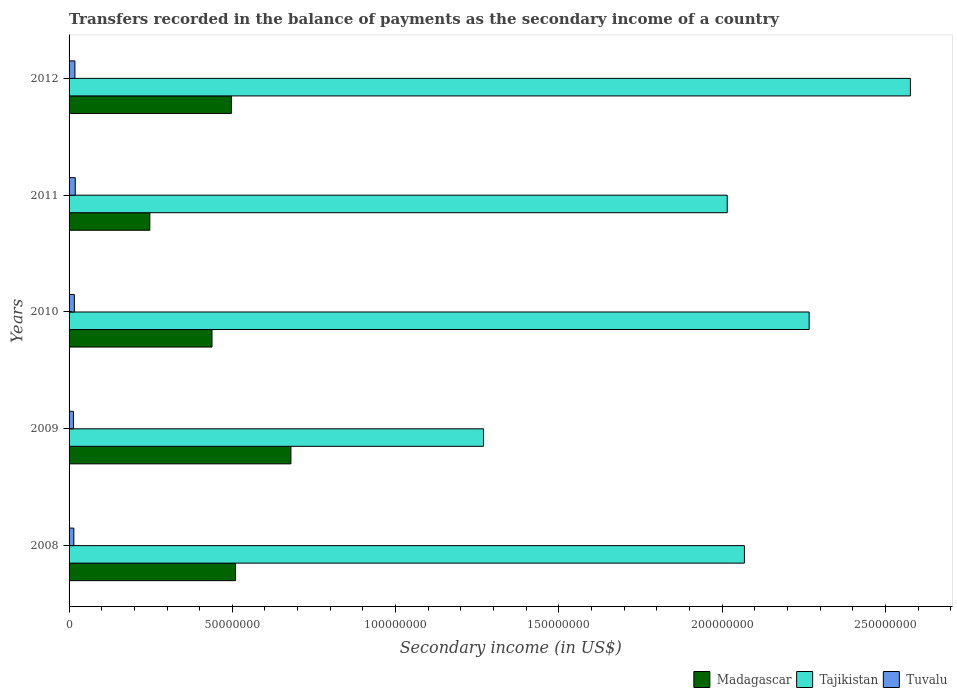How many different coloured bars are there?
Ensure brevity in your answer.  3. How many groups of bars are there?
Your answer should be very brief. 5. Are the number of bars per tick equal to the number of legend labels?
Your answer should be very brief. Yes. How many bars are there on the 4th tick from the top?
Offer a terse response. 3. What is the label of the 5th group of bars from the top?
Make the answer very short. 2008. In how many cases, is the number of bars for a given year not equal to the number of legend labels?
Provide a succinct answer. 0. What is the secondary income of in Madagascar in 2010?
Offer a very short reply. 4.38e+07. Across all years, what is the maximum secondary income of in Tajikistan?
Offer a very short reply. 2.58e+08. Across all years, what is the minimum secondary income of in Tuvalu?
Offer a terse response. 1.33e+06. In which year was the secondary income of in Tuvalu maximum?
Provide a succinct answer. 2011. What is the total secondary income of in Madagascar in the graph?
Provide a succinct answer. 2.37e+08. What is the difference between the secondary income of in Madagascar in 2011 and that in 2012?
Your answer should be compact. -2.50e+07. What is the difference between the secondary income of in Madagascar in 2010 and the secondary income of in Tajikistan in 2008?
Give a very brief answer. -1.63e+08. What is the average secondary income of in Madagascar per year?
Offer a terse response. 4.74e+07. In the year 2012, what is the difference between the secondary income of in Tuvalu and secondary income of in Madagascar?
Give a very brief answer. -4.79e+07. In how many years, is the secondary income of in Madagascar greater than 240000000 US$?
Your answer should be compact. 0. What is the ratio of the secondary income of in Madagascar in 2009 to that in 2012?
Provide a short and direct response. 1.37. Is the difference between the secondary income of in Tuvalu in 2009 and 2012 greater than the difference between the secondary income of in Madagascar in 2009 and 2012?
Provide a short and direct response. No. What is the difference between the highest and the second highest secondary income of in Madagascar?
Your response must be concise. 1.70e+07. What is the difference between the highest and the lowest secondary income of in Madagascar?
Your response must be concise. 4.32e+07. In how many years, is the secondary income of in Tuvalu greater than the average secondary income of in Tuvalu taken over all years?
Offer a very short reply. 2. What does the 2nd bar from the top in 2012 represents?
Your answer should be very brief. Tajikistan. What does the 2nd bar from the bottom in 2009 represents?
Keep it short and to the point. Tajikistan. Is it the case that in every year, the sum of the secondary income of in Madagascar and secondary income of in Tuvalu is greater than the secondary income of in Tajikistan?
Your response must be concise. No. Are all the bars in the graph horizontal?
Provide a succinct answer. Yes. What is the difference between two consecutive major ticks on the X-axis?
Provide a succinct answer. 5.00e+07. Does the graph contain grids?
Ensure brevity in your answer.  No. Where does the legend appear in the graph?
Keep it short and to the point. Bottom right. How many legend labels are there?
Give a very brief answer. 3. How are the legend labels stacked?
Provide a succinct answer. Horizontal. What is the title of the graph?
Provide a succinct answer. Transfers recorded in the balance of payments as the secondary income of a country. Does "Brunei Darussalam" appear as one of the legend labels in the graph?
Ensure brevity in your answer.  No. What is the label or title of the X-axis?
Give a very brief answer. Secondary income (in US$). What is the label or title of the Y-axis?
Your answer should be very brief. Years. What is the Secondary income (in US$) in Madagascar in 2008?
Offer a very short reply. 5.10e+07. What is the Secondary income (in US$) of Tajikistan in 2008?
Your answer should be compact. 2.07e+08. What is the Secondary income (in US$) in Tuvalu in 2008?
Provide a succinct answer. 1.46e+06. What is the Secondary income (in US$) of Madagascar in 2009?
Your answer should be compact. 6.79e+07. What is the Secondary income (in US$) of Tajikistan in 2009?
Offer a very short reply. 1.27e+08. What is the Secondary income (in US$) of Tuvalu in 2009?
Ensure brevity in your answer.  1.33e+06. What is the Secondary income (in US$) in Madagascar in 2010?
Make the answer very short. 4.38e+07. What is the Secondary income (in US$) of Tajikistan in 2010?
Offer a terse response. 2.27e+08. What is the Secondary income (in US$) of Tuvalu in 2010?
Ensure brevity in your answer.  1.61e+06. What is the Secondary income (in US$) in Madagascar in 2011?
Offer a very short reply. 2.47e+07. What is the Secondary income (in US$) of Tajikistan in 2011?
Provide a succinct answer. 2.02e+08. What is the Secondary income (in US$) in Tuvalu in 2011?
Make the answer very short. 1.89e+06. What is the Secondary income (in US$) in Madagascar in 2012?
Give a very brief answer. 4.97e+07. What is the Secondary income (in US$) in Tajikistan in 2012?
Provide a succinct answer. 2.58e+08. What is the Secondary income (in US$) in Tuvalu in 2012?
Provide a short and direct response. 1.79e+06. Across all years, what is the maximum Secondary income (in US$) of Madagascar?
Keep it short and to the point. 6.79e+07. Across all years, what is the maximum Secondary income (in US$) of Tajikistan?
Make the answer very short. 2.58e+08. Across all years, what is the maximum Secondary income (in US$) in Tuvalu?
Give a very brief answer. 1.89e+06. Across all years, what is the minimum Secondary income (in US$) of Madagascar?
Give a very brief answer. 2.47e+07. Across all years, what is the minimum Secondary income (in US$) in Tajikistan?
Your answer should be compact. 1.27e+08. Across all years, what is the minimum Secondary income (in US$) of Tuvalu?
Offer a very short reply. 1.33e+06. What is the total Secondary income (in US$) of Madagascar in the graph?
Give a very brief answer. 2.37e+08. What is the total Secondary income (in US$) in Tajikistan in the graph?
Your answer should be very brief. 1.02e+09. What is the total Secondary income (in US$) of Tuvalu in the graph?
Keep it short and to the point. 8.09e+06. What is the difference between the Secondary income (in US$) in Madagascar in 2008 and that in 2009?
Your answer should be compact. -1.70e+07. What is the difference between the Secondary income (in US$) in Tajikistan in 2008 and that in 2009?
Provide a short and direct response. 7.99e+07. What is the difference between the Secondary income (in US$) in Tuvalu in 2008 and that in 2009?
Your answer should be very brief. 1.27e+05. What is the difference between the Secondary income (in US$) of Madagascar in 2008 and that in 2010?
Your answer should be very brief. 7.18e+06. What is the difference between the Secondary income (in US$) of Tajikistan in 2008 and that in 2010?
Provide a succinct answer. -1.98e+07. What is the difference between the Secondary income (in US$) of Tuvalu in 2008 and that in 2010?
Keep it short and to the point. -1.53e+05. What is the difference between the Secondary income (in US$) of Madagascar in 2008 and that in 2011?
Provide a succinct answer. 2.62e+07. What is the difference between the Secondary income (in US$) in Tajikistan in 2008 and that in 2011?
Offer a terse response. 5.26e+06. What is the difference between the Secondary income (in US$) of Tuvalu in 2008 and that in 2011?
Keep it short and to the point. -4.32e+05. What is the difference between the Secondary income (in US$) in Madagascar in 2008 and that in 2012?
Provide a short and direct response. 1.25e+06. What is the difference between the Secondary income (in US$) of Tajikistan in 2008 and that in 2012?
Provide a succinct answer. -5.08e+07. What is the difference between the Secondary income (in US$) of Tuvalu in 2008 and that in 2012?
Make the answer very short. -3.24e+05. What is the difference between the Secondary income (in US$) in Madagascar in 2009 and that in 2010?
Your answer should be very brief. 2.42e+07. What is the difference between the Secondary income (in US$) of Tajikistan in 2009 and that in 2010?
Offer a very short reply. -9.97e+07. What is the difference between the Secondary income (in US$) in Tuvalu in 2009 and that in 2010?
Ensure brevity in your answer.  -2.80e+05. What is the difference between the Secondary income (in US$) in Madagascar in 2009 and that in 2011?
Keep it short and to the point. 4.32e+07. What is the difference between the Secondary income (in US$) in Tajikistan in 2009 and that in 2011?
Make the answer very short. -7.46e+07. What is the difference between the Secondary income (in US$) in Tuvalu in 2009 and that in 2011?
Your response must be concise. -5.59e+05. What is the difference between the Secondary income (in US$) of Madagascar in 2009 and that in 2012?
Your answer should be very brief. 1.82e+07. What is the difference between the Secondary income (in US$) of Tajikistan in 2009 and that in 2012?
Offer a very short reply. -1.31e+08. What is the difference between the Secondary income (in US$) of Tuvalu in 2009 and that in 2012?
Provide a short and direct response. -4.51e+05. What is the difference between the Secondary income (in US$) of Madagascar in 2010 and that in 2011?
Keep it short and to the point. 1.90e+07. What is the difference between the Secondary income (in US$) in Tajikistan in 2010 and that in 2011?
Keep it short and to the point. 2.51e+07. What is the difference between the Secondary income (in US$) of Tuvalu in 2010 and that in 2011?
Provide a short and direct response. -2.80e+05. What is the difference between the Secondary income (in US$) of Madagascar in 2010 and that in 2012?
Keep it short and to the point. -5.93e+06. What is the difference between the Secondary income (in US$) in Tajikistan in 2010 and that in 2012?
Give a very brief answer. -3.10e+07. What is the difference between the Secondary income (in US$) in Tuvalu in 2010 and that in 2012?
Ensure brevity in your answer.  -1.71e+05. What is the difference between the Secondary income (in US$) of Madagascar in 2011 and that in 2012?
Your answer should be very brief. -2.50e+07. What is the difference between the Secondary income (in US$) in Tajikistan in 2011 and that in 2012?
Ensure brevity in your answer.  -5.61e+07. What is the difference between the Secondary income (in US$) in Tuvalu in 2011 and that in 2012?
Your answer should be very brief. 1.08e+05. What is the difference between the Secondary income (in US$) in Madagascar in 2008 and the Secondary income (in US$) in Tajikistan in 2009?
Your response must be concise. -7.60e+07. What is the difference between the Secondary income (in US$) of Madagascar in 2008 and the Secondary income (in US$) of Tuvalu in 2009?
Offer a terse response. 4.96e+07. What is the difference between the Secondary income (in US$) of Tajikistan in 2008 and the Secondary income (in US$) of Tuvalu in 2009?
Ensure brevity in your answer.  2.05e+08. What is the difference between the Secondary income (in US$) in Madagascar in 2008 and the Secondary income (in US$) in Tajikistan in 2010?
Provide a succinct answer. -1.76e+08. What is the difference between the Secondary income (in US$) of Madagascar in 2008 and the Secondary income (in US$) of Tuvalu in 2010?
Provide a short and direct response. 4.93e+07. What is the difference between the Secondary income (in US$) of Tajikistan in 2008 and the Secondary income (in US$) of Tuvalu in 2010?
Give a very brief answer. 2.05e+08. What is the difference between the Secondary income (in US$) in Madagascar in 2008 and the Secondary income (in US$) in Tajikistan in 2011?
Your answer should be compact. -1.51e+08. What is the difference between the Secondary income (in US$) in Madagascar in 2008 and the Secondary income (in US$) in Tuvalu in 2011?
Provide a succinct answer. 4.91e+07. What is the difference between the Secondary income (in US$) in Tajikistan in 2008 and the Secondary income (in US$) in Tuvalu in 2011?
Make the answer very short. 2.05e+08. What is the difference between the Secondary income (in US$) of Madagascar in 2008 and the Secondary income (in US$) of Tajikistan in 2012?
Provide a short and direct response. -2.07e+08. What is the difference between the Secondary income (in US$) in Madagascar in 2008 and the Secondary income (in US$) in Tuvalu in 2012?
Offer a very short reply. 4.92e+07. What is the difference between the Secondary income (in US$) in Tajikistan in 2008 and the Secondary income (in US$) in Tuvalu in 2012?
Offer a very short reply. 2.05e+08. What is the difference between the Secondary income (in US$) of Madagascar in 2009 and the Secondary income (in US$) of Tajikistan in 2010?
Your answer should be very brief. -1.59e+08. What is the difference between the Secondary income (in US$) in Madagascar in 2009 and the Secondary income (in US$) in Tuvalu in 2010?
Keep it short and to the point. 6.63e+07. What is the difference between the Secondary income (in US$) in Tajikistan in 2009 and the Secondary income (in US$) in Tuvalu in 2010?
Make the answer very short. 1.25e+08. What is the difference between the Secondary income (in US$) in Madagascar in 2009 and the Secondary income (in US$) in Tajikistan in 2011?
Offer a very short reply. -1.34e+08. What is the difference between the Secondary income (in US$) in Madagascar in 2009 and the Secondary income (in US$) in Tuvalu in 2011?
Provide a succinct answer. 6.60e+07. What is the difference between the Secondary income (in US$) in Tajikistan in 2009 and the Secondary income (in US$) in Tuvalu in 2011?
Your response must be concise. 1.25e+08. What is the difference between the Secondary income (in US$) in Madagascar in 2009 and the Secondary income (in US$) in Tajikistan in 2012?
Offer a very short reply. -1.90e+08. What is the difference between the Secondary income (in US$) in Madagascar in 2009 and the Secondary income (in US$) in Tuvalu in 2012?
Provide a short and direct response. 6.62e+07. What is the difference between the Secondary income (in US$) in Tajikistan in 2009 and the Secondary income (in US$) in Tuvalu in 2012?
Keep it short and to the point. 1.25e+08. What is the difference between the Secondary income (in US$) of Madagascar in 2010 and the Secondary income (in US$) of Tajikistan in 2011?
Your answer should be very brief. -1.58e+08. What is the difference between the Secondary income (in US$) of Madagascar in 2010 and the Secondary income (in US$) of Tuvalu in 2011?
Make the answer very short. 4.19e+07. What is the difference between the Secondary income (in US$) of Tajikistan in 2010 and the Secondary income (in US$) of Tuvalu in 2011?
Your answer should be compact. 2.25e+08. What is the difference between the Secondary income (in US$) of Madagascar in 2010 and the Secondary income (in US$) of Tajikistan in 2012?
Make the answer very short. -2.14e+08. What is the difference between the Secondary income (in US$) in Madagascar in 2010 and the Secondary income (in US$) in Tuvalu in 2012?
Make the answer very short. 4.20e+07. What is the difference between the Secondary income (in US$) of Tajikistan in 2010 and the Secondary income (in US$) of Tuvalu in 2012?
Give a very brief answer. 2.25e+08. What is the difference between the Secondary income (in US$) in Madagascar in 2011 and the Secondary income (in US$) in Tajikistan in 2012?
Give a very brief answer. -2.33e+08. What is the difference between the Secondary income (in US$) of Madagascar in 2011 and the Secondary income (in US$) of Tuvalu in 2012?
Offer a terse response. 2.29e+07. What is the difference between the Secondary income (in US$) of Tajikistan in 2011 and the Secondary income (in US$) of Tuvalu in 2012?
Provide a succinct answer. 2.00e+08. What is the average Secondary income (in US$) in Madagascar per year?
Offer a terse response. 4.74e+07. What is the average Secondary income (in US$) of Tajikistan per year?
Keep it short and to the point. 2.04e+08. What is the average Secondary income (in US$) in Tuvalu per year?
Keep it short and to the point. 1.62e+06. In the year 2008, what is the difference between the Secondary income (in US$) of Madagascar and Secondary income (in US$) of Tajikistan?
Make the answer very short. -1.56e+08. In the year 2008, what is the difference between the Secondary income (in US$) of Madagascar and Secondary income (in US$) of Tuvalu?
Your response must be concise. 4.95e+07. In the year 2008, what is the difference between the Secondary income (in US$) in Tajikistan and Secondary income (in US$) in Tuvalu?
Offer a very short reply. 2.05e+08. In the year 2009, what is the difference between the Secondary income (in US$) of Madagascar and Secondary income (in US$) of Tajikistan?
Give a very brief answer. -5.90e+07. In the year 2009, what is the difference between the Secondary income (in US$) in Madagascar and Secondary income (in US$) in Tuvalu?
Ensure brevity in your answer.  6.66e+07. In the year 2009, what is the difference between the Secondary income (in US$) in Tajikistan and Secondary income (in US$) in Tuvalu?
Offer a terse response. 1.26e+08. In the year 2010, what is the difference between the Secondary income (in US$) in Madagascar and Secondary income (in US$) in Tajikistan?
Ensure brevity in your answer.  -1.83e+08. In the year 2010, what is the difference between the Secondary income (in US$) of Madagascar and Secondary income (in US$) of Tuvalu?
Your response must be concise. 4.22e+07. In the year 2010, what is the difference between the Secondary income (in US$) of Tajikistan and Secondary income (in US$) of Tuvalu?
Your answer should be compact. 2.25e+08. In the year 2011, what is the difference between the Secondary income (in US$) of Madagascar and Secondary income (in US$) of Tajikistan?
Offer a terse response. -1.77e+08. In the year 2011, what is the difference between the Secondary income (in US$) in Madagascar and Secondary income (in US$) in Tuvalu?
Provide a short and direct response. 2.28e+07. In the year 2011, what is the difference between the Secondary income (in US$) of Tajikistan and Secondary income (in US$) of Tuvalu?
Make the answer very short. 2.00e+08. In the year 2012, what is the difference between the Secondary income (in US$) of Madagascar and Secondary income (in US$) of Tajikistan?
Provide a succinct answer. -2.08e+08. In the year 2012, what is the difference between the Secondary income (in US$) of Madagascar and Secondary income (in US$) of Tuvalu?
Offer a very short reply. 4.79e+07. In the year 2012, what is the difference between the Secondary income (in US$) in Tajikistan and Secondary income (in US$) in Tuvalu?
Offer a very short reply. 2.56e+08. What is the ratio of the Secondary income (in US$) of Tajikistan in 2008 to that in 2009?
Ensure brevity in your answer.  1.63. What is the ratio of the Secondary income (in US$) of Tuvalu in 2008 to that in 2009?
Give a very brief answer. 1.1. What is the ratio of the Secondary income (in US$) of Madagascar in 2008 to that in 2010?
Make the answer very short. 1.16. What is the ratio of the Secondary income (in US$) of Tajikistan in 2008 to that in 2010?
Make the answer very short. 0.91. What is the ratio of the Secondary income (in US$) in Tuvalu in 2008 to that in 2010?
Give a very brief answer. 0.91. What is the ratio of the Secondary income (in US$) in Madagascar in 2008 to that in 2011?
Your answer should be compact. 2.06. What is the ratio of the Secondary income (in US$) in Tajikistan in 2008 to that in 2011?
Your answer should be very brief. 1.03. What is the ratio of the Secondary income (in US$) of Tuvalu in 2008 to that in 2011?
Your answer should be compact. 0.77. What is the ratio of the Secondary income (in US$) of Madagascar in 2008 to that in 2012?
Your answer should be very brief. 1.03. What is the ratio of the Secondary income (in US$) in Tajikistan in 2008 to that in 2012?
Your answer should be compact. 0.8. What is the ratio of the Secondary income (in US$) of Tuvalu in 2008 to that in 2012?
Keep it short and to the point. 0.82. What is the ratio of the Secondary income (in US$) in Madagascar in 2009 to that in 2010?
Provide a succinct answer. 1.55. What is the ratio of the Secondary income (in US$) in Tajikistan in 2009 to that in 2010?
Your answer should be compact. 0.56. What is the ratio of the Secondary income (in US$) of Tuvalu in 2009 to that in 2010?
Your response must be concise. 0.83. What is the ratio of the Secondary income (in US$) in Madagascar in 2009 to that in 2011?
Ensure brevity in your answer.  2.75. What is the ratio of the Secondary income (in US$) of Tajikistan in 2009 to that in 2011?
Offer a very short reply. 0.63. What is the ratio of the Secondary income (in US$) in Tuvalu in 2009 to that in 2011?
Your answer should be compact. 0.7. What is the ratio of the Secondary income (in US$) in Madagascar in 2009 to that in 2012?
Provide a short and direct response. 1.37. What is the ratio of the Secondary income (in US$) in Tajikistan in 2009 to that in 2012?
Provide a succinct answer. 0.49. What is the ratio of the Secondary income (in US$) of Tuvalu in 2009 to that in 2012?
Keep it short and to the point. 0.75. What is the ratio of the Secondary income (in US$) in Madagascar in 2010 to that in 2011?
Provide a succinct answer. 1.77. What is the ratio of the Secondary income (in US$) in Tajikistan in 2010 to that in 2011?
Your answer should be very brief. 1.12. What is the ratio of the Secondary income (in US$) of Tuvalu in 2010 to that in 2011?
Offer a terse response. 0.85. What is the ratio of the Secondary income (in US$) in Madagascar in 2010 to that in 2012?
Provide a short and direct response. 0.88. What is the ratio of the Secondary income (in US$) of Tajikistan in 2010 to that in 2012?
Provide a succinct answer. 0.88. What is the ratio of the Secondary income (in US$) of Tuvalu in 2010 to that in 2012?
Your answer should be very brief. 0.9. What is the ratio of the Secondary income (in US$) of Madagascar in 2011 to that in 2012?
Give a very brief answer. 0.5. What is the ratio of the Secondary income (in US$) of Tajikistan in 2011 to that in 2012?
Your answer should be compact. 0.78. What is the ratio of the Secondary income (in US$) of Tuvalu in 2011 to that in 2012?
Make the answer very short. 1.06. What is the difference between the highest and the second highest Secondary income (in US$) in Madagascar?
Your response must be concise. 1.70e+07. What is the difference between the highest and the second highest Secondary income (in US$) in Tajikistan?
Your response must be concise. 3.10e+07. What is the difference between the highest and the second highest Secondary income (in US$) in Tuvalu?
Give a very brief answer. 1.08e+05. What is the difference between the highest and the lowest Secondary income (in US$) in Madagascar?
Your response must be concise. 4.32e+07. What is the difference between the highest and the lowest Secondary income (in US$) in Tajikistan?
Your response must be concise. 1.31e+08. What is the difference between the highest and the lowest Secondary income (in US$) in Tuvalu?
Offer a very short reply. 5.59e+05. 